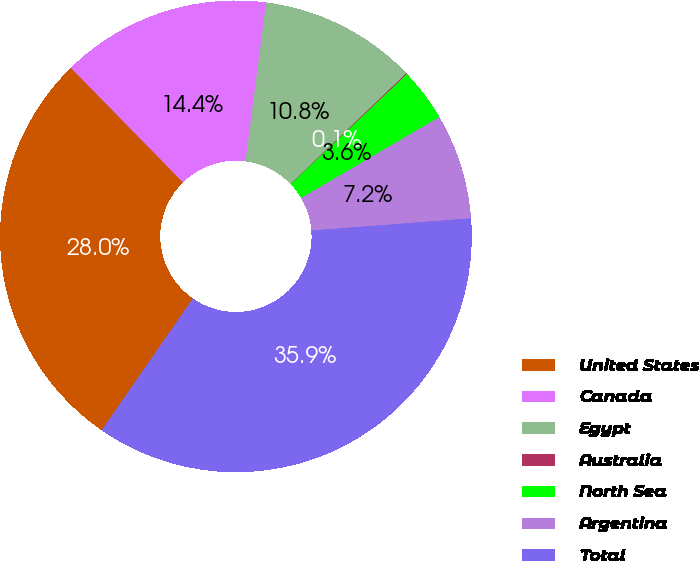Convert chart. <chart><loc_0><loc_0><loc_500><loc_500><pie_chart><fcel>United States<fcel>Canada<fcel>Egypt<fcel>Australia<fcel>North Sea<fcel>Argentina<fcel>Total<nl><fcel>28.03%<fcel>14.38%<fcel>10.8%<fcel>0.07%<fcel>3.64%<fcel>7.22%<fcel>35.85%<nl></chart> 